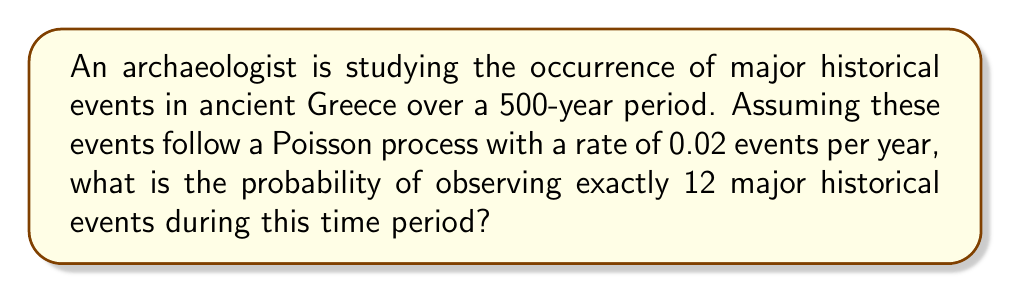Give your solution to this math problem. To solve this problem, we'll use the Poisson distribution formula:

$$P(X = k) = \frac{e^{-\lambda} \lambda^k}{k!}$$

Where:
$X$ is the number of events
$k$ is the specific number of events we're interested in
$\lambda$ is the average number of events in the given time period

Step 1: Calculate $\lambda$
$\lambda = \text{rate} \times \text{time period}$
$\lambda = 0.02 \times 500 = 10$

Step 2: Plug values into the Poisson distribution formula
$P(X = 12) = \frac{e^{-10} 10^{12}}{12!}$

Step 3: Calculate the result
Using a calculator or computer:
$P(X = 12) \approx 0.0948$

Therefore, the probability of observing exactly 12 major historical events during this 500-year period is approximately 0.0948 or 9.48%.
Answer: 0.0948 